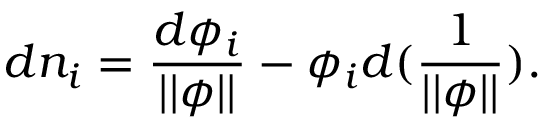<formula> <loc_0><loc_0><loc_500><loc_500>d n _ { i } = \frac { d \phi _ { i } } { | | \phi | | } - \phi _ { i } d ( { \frac { 1 } | | \phi | | } } ) .</formula> 